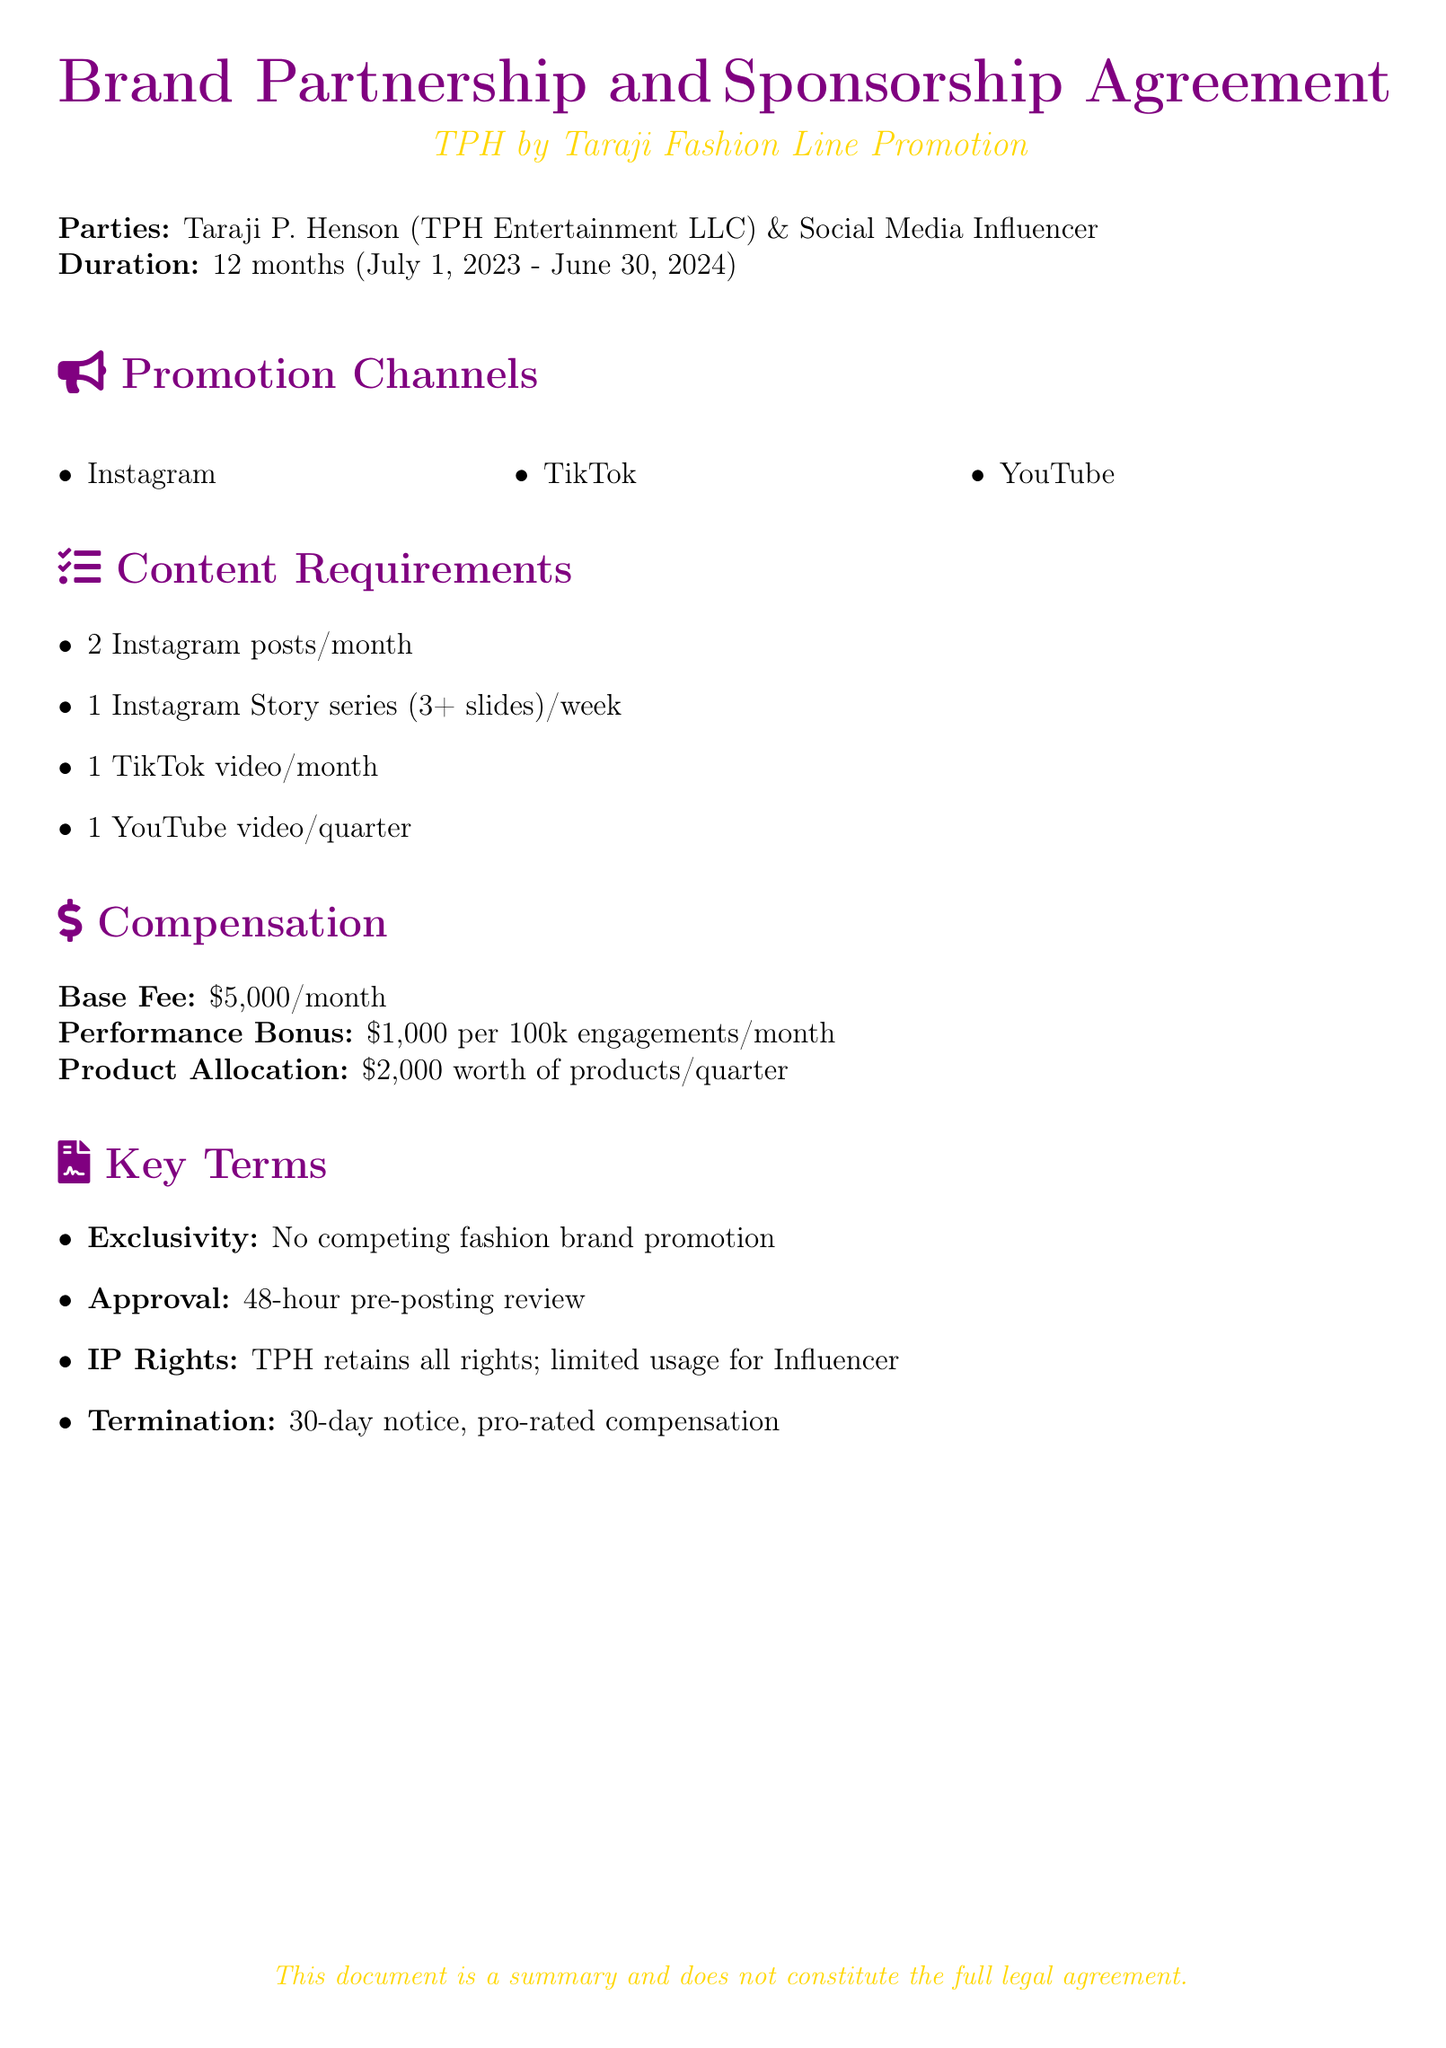What is the duration of the agreement? The duration of the agreement is specified in the document as 12 months, from July 1, 2023, to June 30, 2024.
Answer: 12 months What is the base fee per month? The document outlines the base fee for the influencer as part of the compensation section.
Answer: $5,000 How many Instagram posts are required per month? The content requirements detail the number of Instagram posts the influencer must create each month.
Answer: 2 posts/month What is the performance bonus amount per 100k engagements? The compensation section provides details on the performance bonus.
Answer: $1,000 What is the exclusivity clause about? The key terms state that the influencer cannot promote competing fashion brands during the agreement.
Answer: No competing fashion brand promotion How often does the influencer need to post a YouTube video? The content requirements specify the frequency of YouTube video posts required from the influencer.
Answer: 1 video/quarter What are the key terms related to termination? The key terms section describes the notice period required for termination.
Answer: 30-day notice What is the product allocation value per quarter? The compensation section mentions the value of products allocated to the influencer each quarter.
Answer: $2,000 worth of products/quarter What is the pre-posting review period mentioned? The key terms section includes information about the approval process before posting content.
Answer: 48-hour pre-posting review 